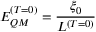Convert formula to latex. <formula><loc_0><loc_0><loc_500><loc_500>E _ { Q M } ^ { ( T = 0 ) } = \frac { \xi _ { 0 } } { L ^ { ( T = 0 ) } }</formula> 